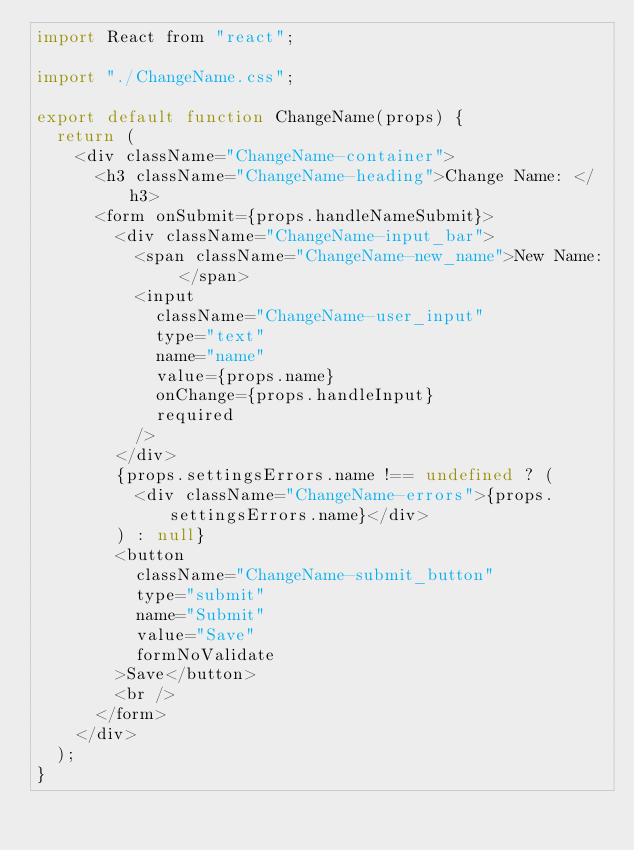Convert code to text. <code><loc_0><loc_0><loc_500><loc_500><_JavaScript_>import React from "react";

import "./ChangeName.css";

export default function ChangeName(props) {
  return (
    <div className="ChangeName-container">
      <h3 className="ChangeName-heading">Change Name: </h3>
      <form onSubmit={props.handleNameSubmit}>
        <div className="ChangeName-input_bar">
          <span className="ChangeName-new_name">New Name: </span>
          <input
            className="ChangeName-user_input"
            type="text"
            name="name"
            value={props.name}
            onChange={props.handleInput}
            required
          />
        </div>
        {props.settingsErrors.name !== undefined ? (
          <div className="ChangeName-errors">{props.settingsErrors.name}</div>
        ) : null}
        <button
          className="ChangeName-submit_button"
          type="submit"
          name="Submit"
          value="Save"
          formNoValidate
        >Save</button>
        <br />
      </form>
    </div>
  );
}
</code> 